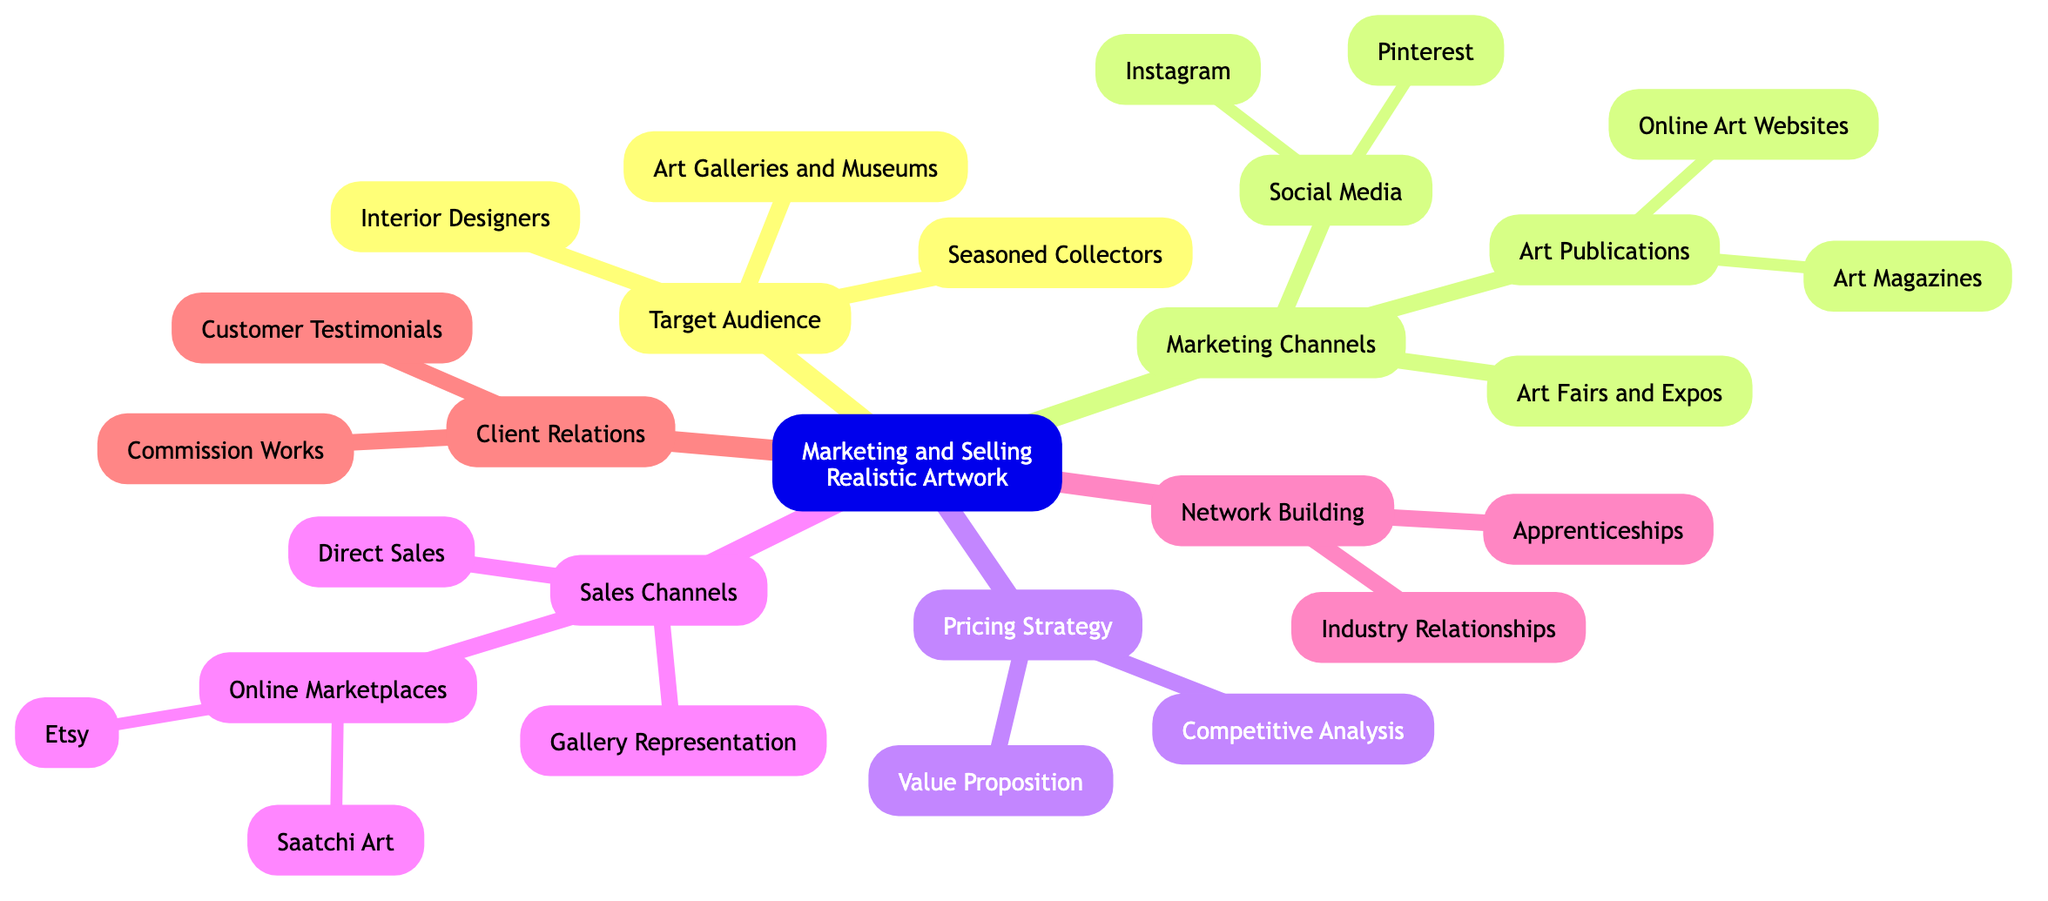What are the three categories under "Target Audience"? The diagram specifies three categories listed under "Target Audience": "Seasoned Collectors," "Art Galleries and Museums," and "Interior Designers."
Answer: Seasoned Collectors, Art Galleries and Museums, Interior Designers How many marketing channels are listed in the diagram? The diagram has a total of 3 main marketing channels: "Social Media," "Art Publications," and "Art Fairs and Expos."
Answer: 3 What is the primary focus of the "Value Proposition"? The "Value Proposition" emphasizes the technical skill, time investment, and materials used in your paintings according to the diagram.
Answer: Technical skill, time investment, and materials Which online marketplace is specifically mentioned for emerging artists? The diagram indicates that "Etsy" is the online marketplace mentioned for emerging artists to sell their work directly to consumers.
Answer: Etsy What is the relationship between "Commission Works" and "Client Relations"? "Commission Works" is a subcategory under "Client Relations," indicating that it specifically relates to how artists engage with their clients by offering custom pieces.
Answer: Subcategory under Client Relations What are the two parts of "Network Building"? The diagram shows that "Network Building" consists of "Industry Relationships" and "Apprenticeships."
Answer: Industry Relationships, Apprenticeships How many nodes are under "Sales Channels"? There are a total of 3 nodes listed under "Sales Channels": "Direct Sales," "Gallery Representation," and "Online Marketplaces."
Answer: 3 Which marketing channel has "Instagram" and "Pinterest" as subcategories? The marketing channel "Social Media" contains the subcategories "Instagram" and "Pinterest," highlighting social media's role in marketing realism artwork.
Answer: Social Media What type of works does "Art Magazines" focus on? The diagram suggests that "Art Magazines" focuses on submitting works to platforms like "Art in America" or "The Artist's Magazine," which are known for featuring art and artists.
Answer: Submitting works to art-focused platforms 